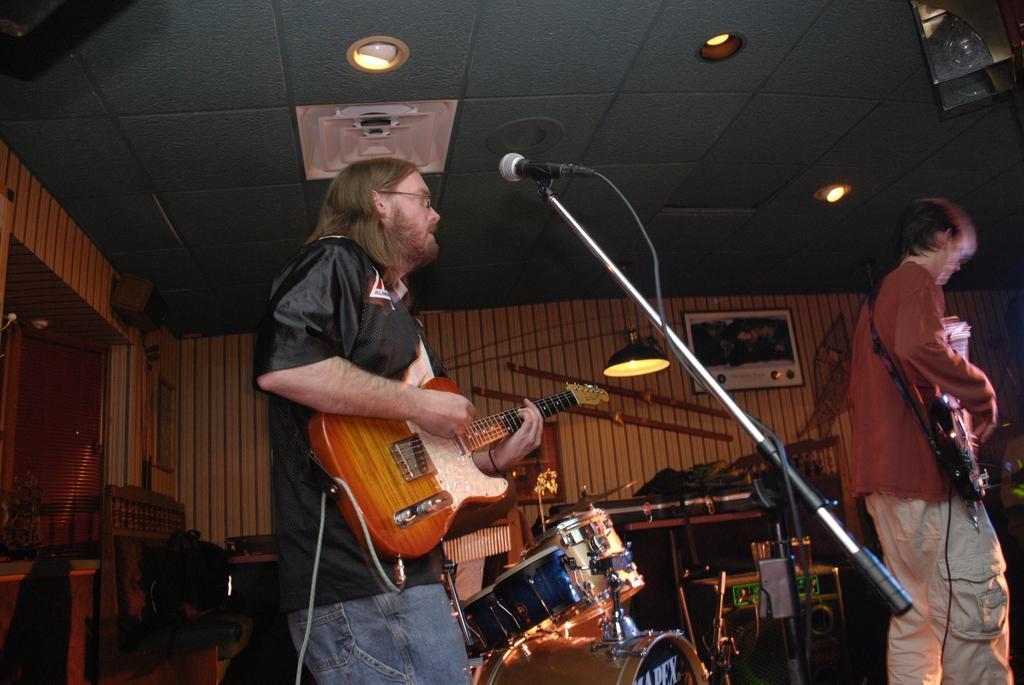Could you give a brief overview of what you see in this image? The person wearing black shirt is playing guitar in front of a mic and there is another person playing guitar in front of him and there are drums beside them. 